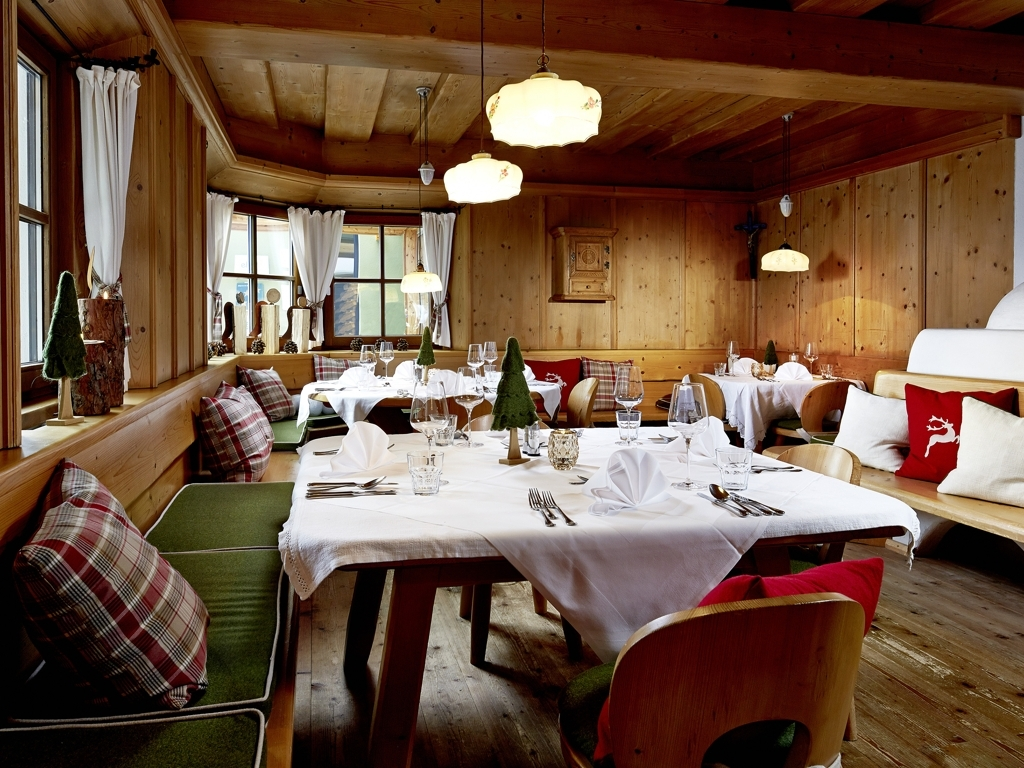Could you describe the types of occasions that might be celebrated in this dining setting? This dining setting, with its intimate ambiance complemented by elegant table settings and comfortable seating, is ideal for a variety of occasions. It could be the perfect backdrop for family gatherings, romantic dinners, or celebrations such as birthdays and anniversaries. The warm atmosphere also makes it suitable for festive occasions like Christmas dinners. Moreover, it could serve as a sophisticated space for small corporate events or retreats that seek a blend of luxury and homeliness. 